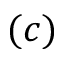Convert formula to latex. <formula><loc_0><loc_0><loc_500><loc_500>( c )</formula> 